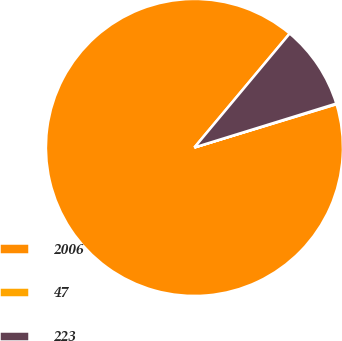<chart> <loc_0><loc_0><loc_500><loc_500><pie_chart><fcel>2006<fcel>47<fcel>223<nl><fcel>90.78%<fcel>0.07%<fcel>9.14%<nl></chart> 